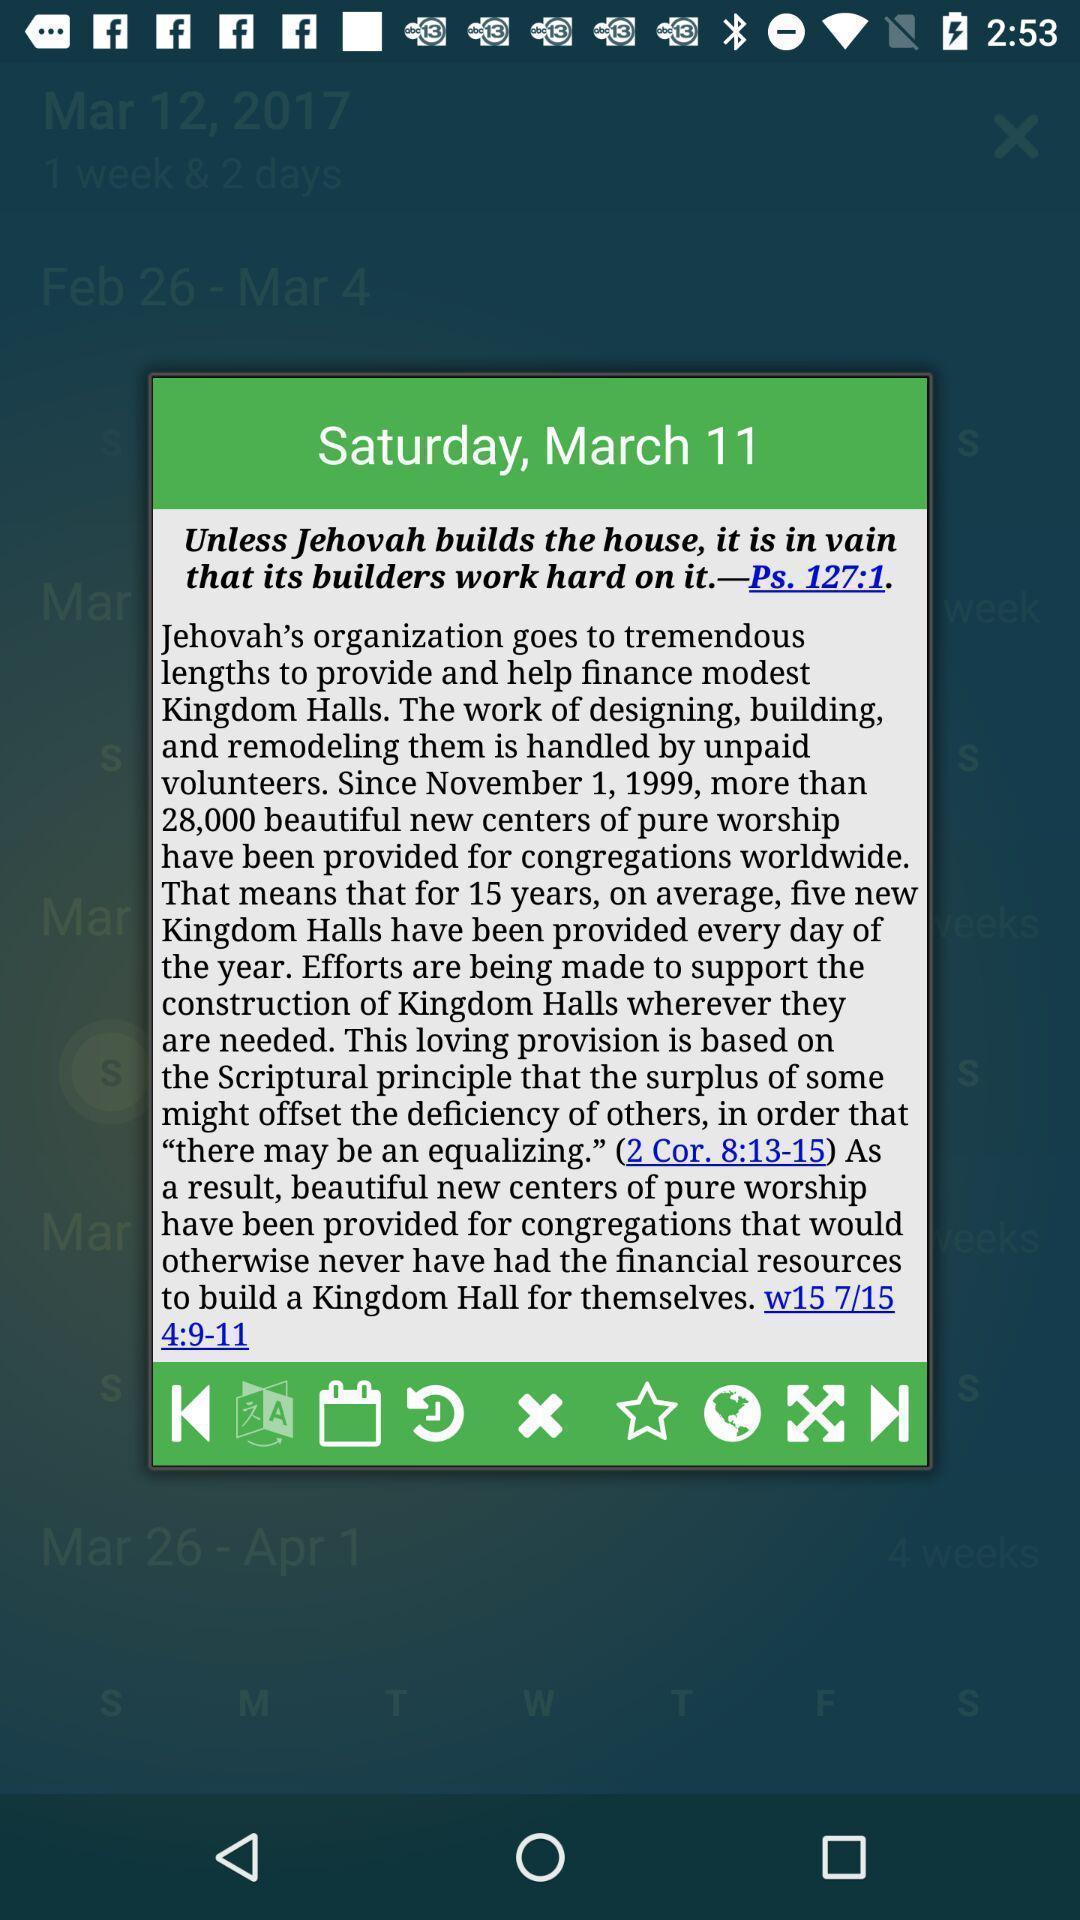Describe the content in this image. Screen displaying the content in a holy book. 